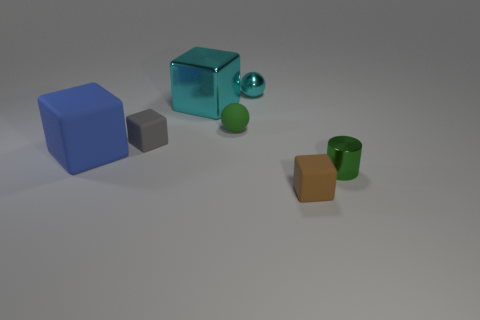Subtract 1 blocks. How many blocks are left? 3 Subtract all cyan cylinders. Subtract all green blocks. How many cylinders are left? 1 Add 3 yellow rubber blocks. How many objects exist? 10 Subtract all cylinders. How many objects are left? 6 Subtract 0 yellow spheres. How many objects are left? 7 Subtract all green shiny cylinders. Subtract all matte objects. How many objects are left? 2 Add 5 cylinders. How many cylinders are left? 6 Add 7 tiny brown things. How many tiny brown things exist? 8 